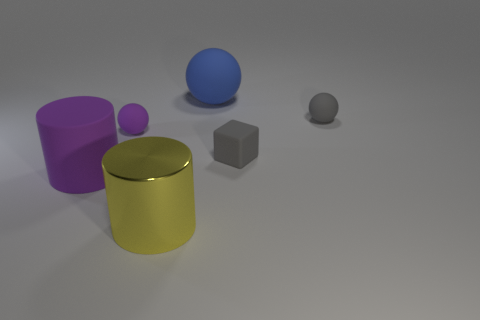There is a cylinder that is to the left of the yellow thing; what is its material?
Give a very brief answer. Rubber. There is a yellow thing that is the same size as the blue object; what material is it?
Your response must be concise. Metal. There is a gray thing that is behind the ball that is left of the big rubber object to the right of the purple cylinder; what is it made of?
Offer a very short reply. Rubber. Does the sphere to the right of the blue sphere have the same size as the tiny gray rubber cube?
Give a very brief answer. Yes. Is the number of purple rubber cylinders greater than the number of matte balls?
Your answer should be compact. No. What number of large things are either blue balls or metallic cylinders?
Keep it short and to the point. 2. What number of other things are there of the same color as the big metallic object?
Provide a succinct answer. 0. How many small yellow cylinders have the same material as the tiny purple sphere?
Your response must be concise. 0. Is the color of the large matte thing that is to the right of the large yellow cylinder the same as the matte cube?
Your answer should be compact. No. How many blue things are big matte things or matte cylinders?
Your answer should be very brief. 1. 